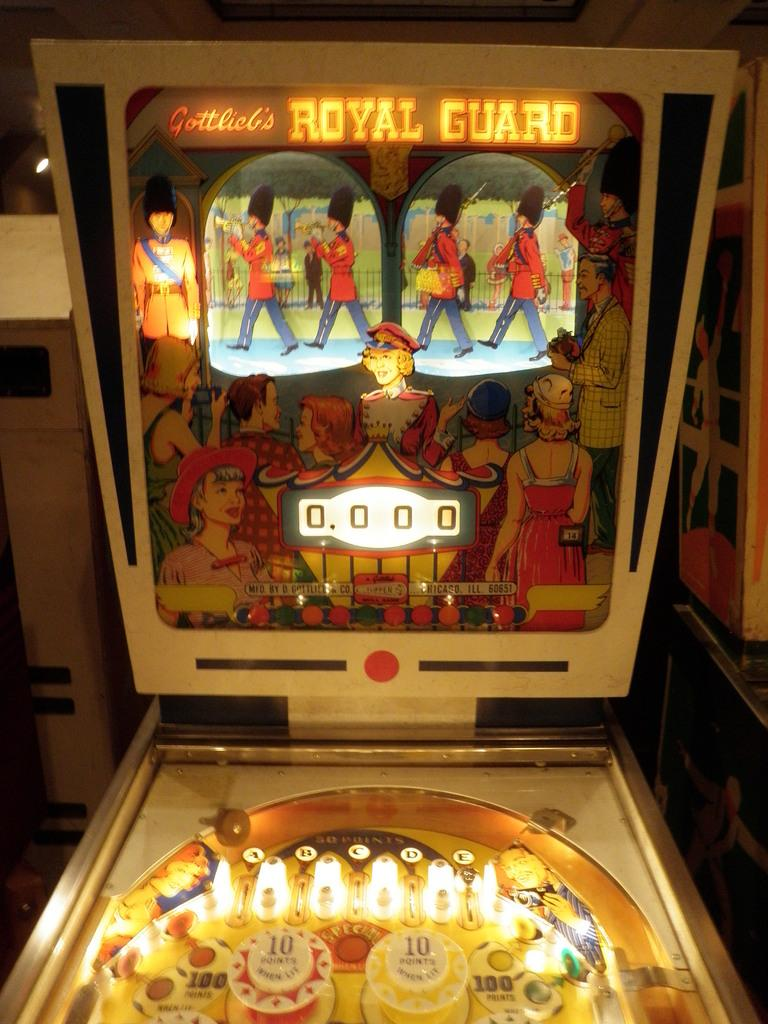What type of electronic device is in the image? There is a gaming console in the image. What is located behind the gaming console? There is an object behind the gaming console. What can be seen in the background of the image? There is a wall visible in the image. How many pages are in the trade book on the gaming console? There is no trade book or pages present in the image; it features a gaming console and an object behind it. 